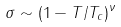Convert formula to latex. <formula><loc_0><loc_0><loc_500><loc_500>\sigma \sim ( 1 - T / T _ { c } ) ^ { \nu }</formula> 